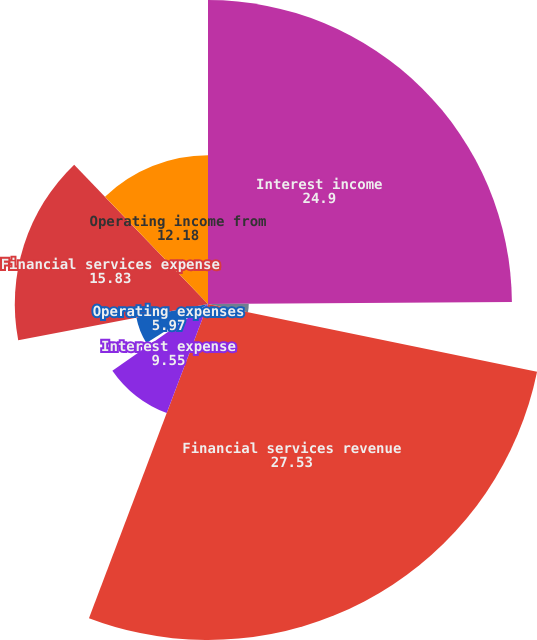Convert chart. <chart><loc_0><loc_0><loc_500><loc_500><pie_chart><fcel>Interest income<fcel>Other income<fcel>Financial services revenue<fcel>Interest expense<fcel>Provision for credit losses<fcel>Operating expenses<fcel>Financial services expense<fcel>Operating income from<nl><fcel>24.9%<fcel>3.34%<fcel>27.53%<fcel>9.55%<fcel>0.71%<fcel>5.97%<fcel>15.83%<fcel>12.18%<nl></chart> 